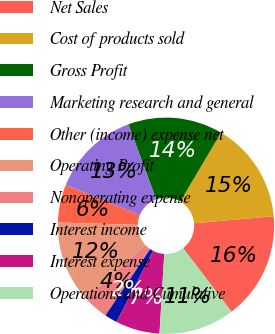<chart> <loc_0><loc_0><loc_500><loc_500><pie_chart><fcel>Net Sales<fcel>Cost of products sold<fcel>Gross Profit<fcel>Marketing research and general<fcel>Other (income) expense net<fcel>Operating Profit<fcel>Nonoperating expense<fcel>Interest income<fcel>Interest expense<fcel>Operations and Cumulative<nl><fcel>16.04%<fcel>15.09%<fcel>14.15%<fcel>13.21%<fcel>5.66%<fcel>12.26%<fcel>3.77%<fcel>1.89%<fcel>6.6%<fcel>11.32%<nl></chart> 